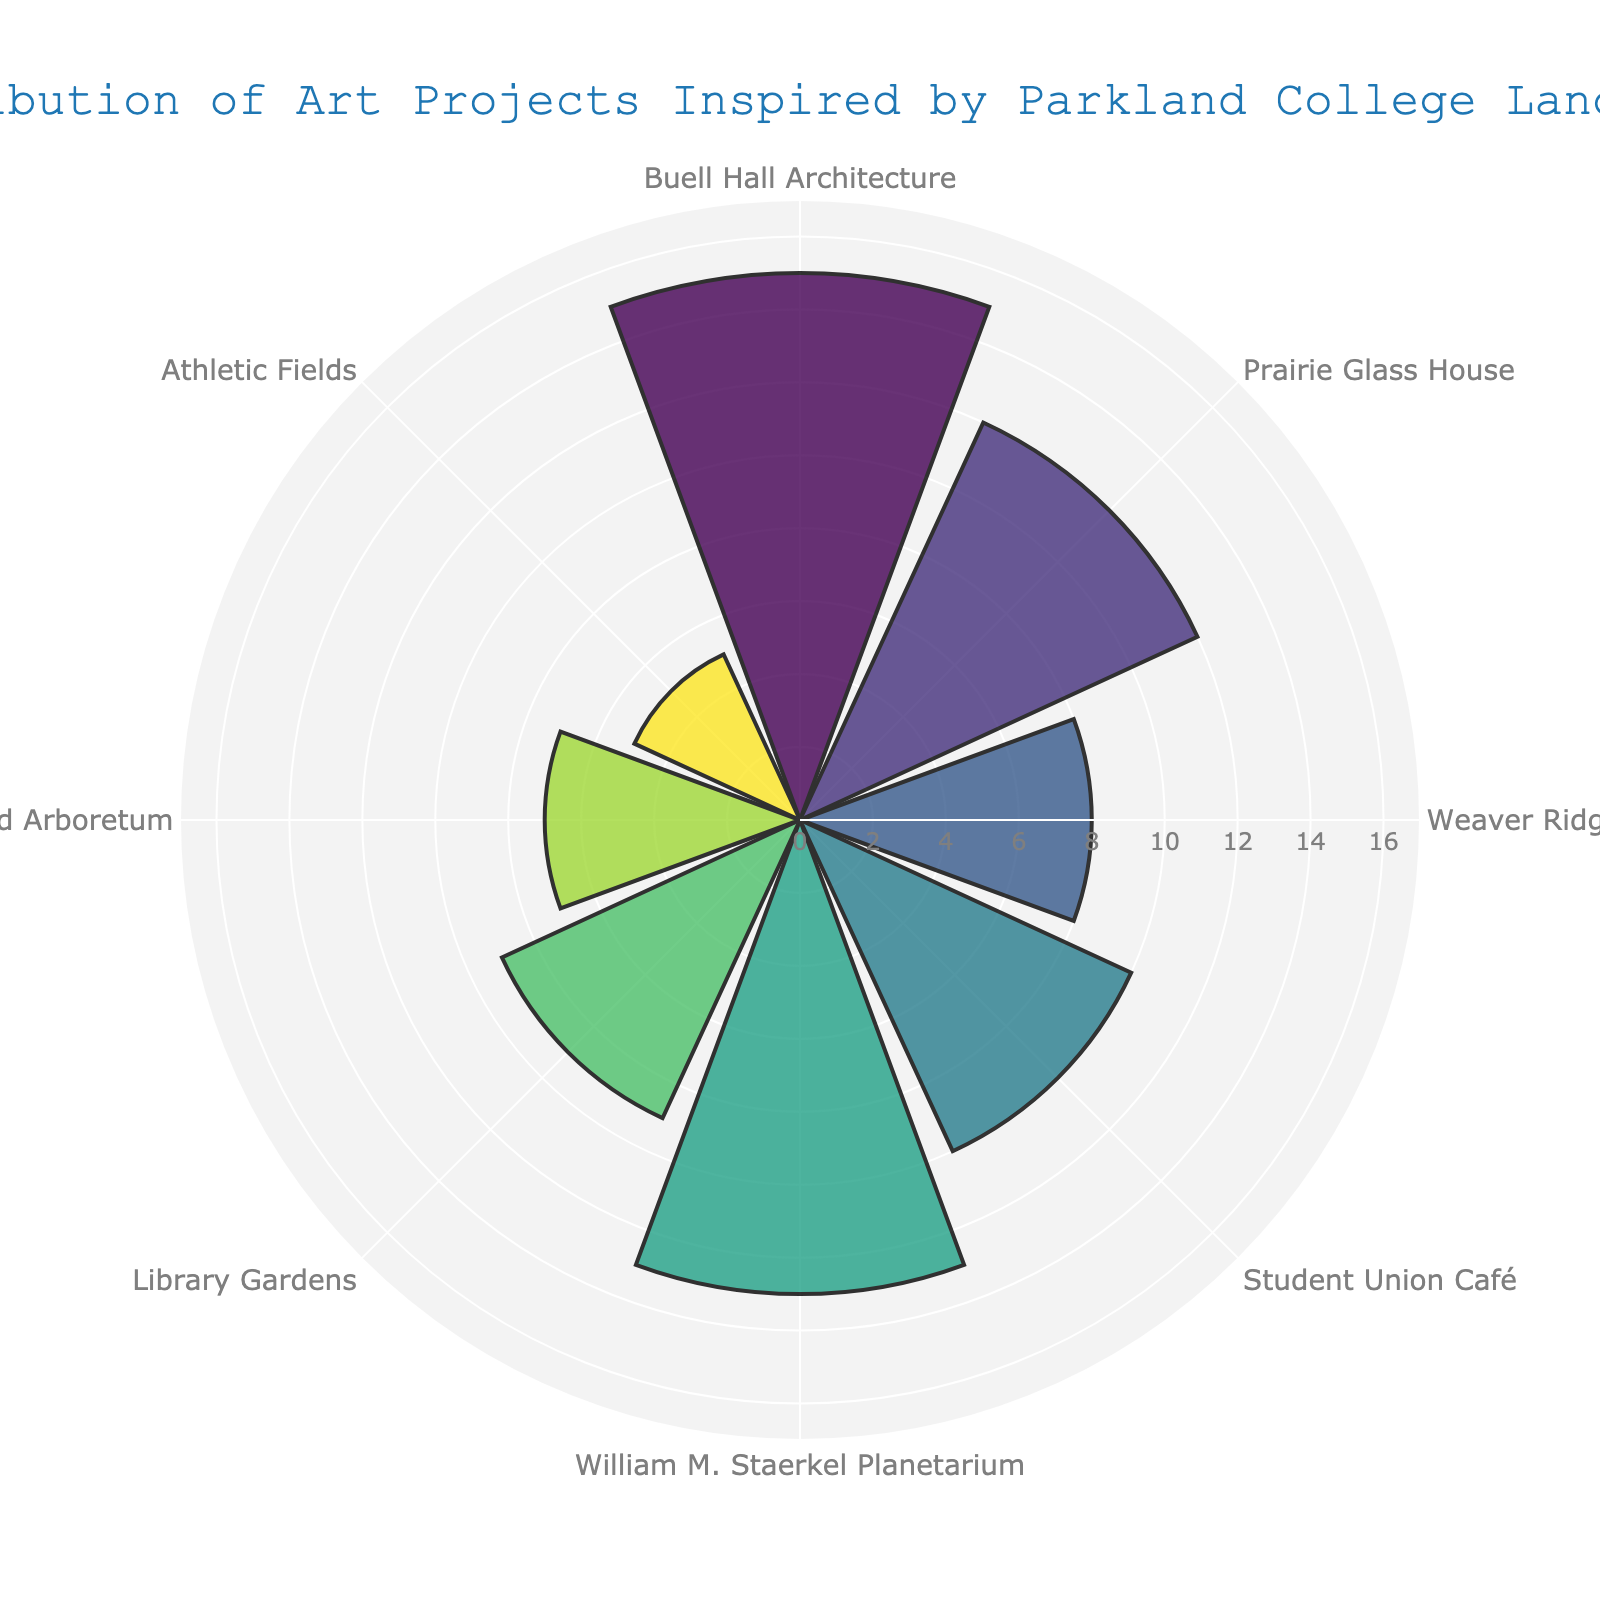Which subject theme has the highest number of art projects? The bar with the highest radial length on the polar area chart corresponds to the subject theme with the highest number of art projects. From the figure, this is the "Buell Hall Architecture" with 15 projects.
Answer: Buell Hall Architecture Which subject theme has the second highest number of art projects? The second longest bar in the polar area chart represents the subject theme with the second highest number of art projects. This is the "William M. Staerkel Planetarium" with 13 projects.
Answer: William M. Staerkel Planetarium How many more art projects are inspired by the Library Gardens compared to the Athletic Fields? To find the number of additional projects inspired by the Library Gardens compared to the Athletic Fields, subtract the number of projects for the Athletic Fields (5) from the Library Gardens (9).
Answer: 4 What is the total number of art projects represented in the chart? Sum the number of projects for all the subject themes listed: 15 + 12 + 8 + 10 + 13 + 9 + 7 + 5. The total is 79.
Answer: 79 What is the average number of art projects per subject theme? The average number of projects per theme is calculated by dividing the total number of projects (79) by the number of themes (8). 79 / 8 = 9.875.
Answer: 9.875 Which subject theme has the least number of art projects? The subject theme with the shortest bar in the polar area chart represents the least number of art projects. This is the "Athletic Fields" with 5 projects.
Answer: Athletic Fields Between Prairie Glass House and Student Union Café, which has more art projects? By comparing the radial lengths of the bars for these two themes, "Prairie Glass House" has 12 projects and "Student Union Café" has 10 projects, so "Prairie Glass House" has more.
Answer: Prairie Glass House How many subject themes have more than 10 art projects? Count the number of themes with bars extending beyond the 10-point radial mark. These themes are "Buell Hall Architecture" (15), "Prairie Glass House" (12), and "William M. Staerkel Planetarium" (13). This makes 3 themes.
Answer: 3 